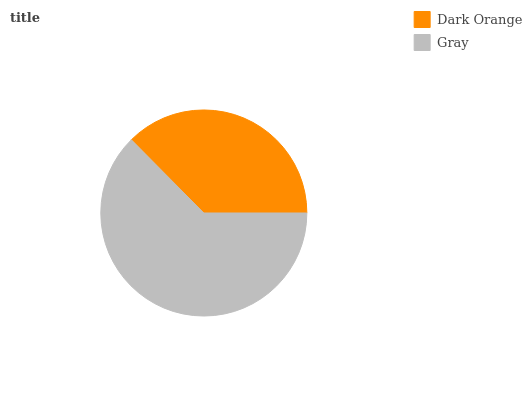Is Dark Orange the minimum?
Answer yes or no. Yes. Is Gray the maximum?
Answer yes or no. Yes. Is Gray the minimum?
Answer yes or no. No. Is Gray greater than Dark Orange?
Answer yes or no. Yes. Is Dark Orange less than Gray?
Answer yes or no. Yes. Is Dark Orange greater than Gray?
Answer yes or no. No. Is Gray less than Dark Orange?
Answer yes or no. No. Is Gray the high median?
Answer yes or no. Yes. Is Dark Orange the low median?
Answer yes or no. Yes. Is Dark Orange the high median?
Answer yes or no. No. Is Gray the low median?
Answer yes or no. No. 